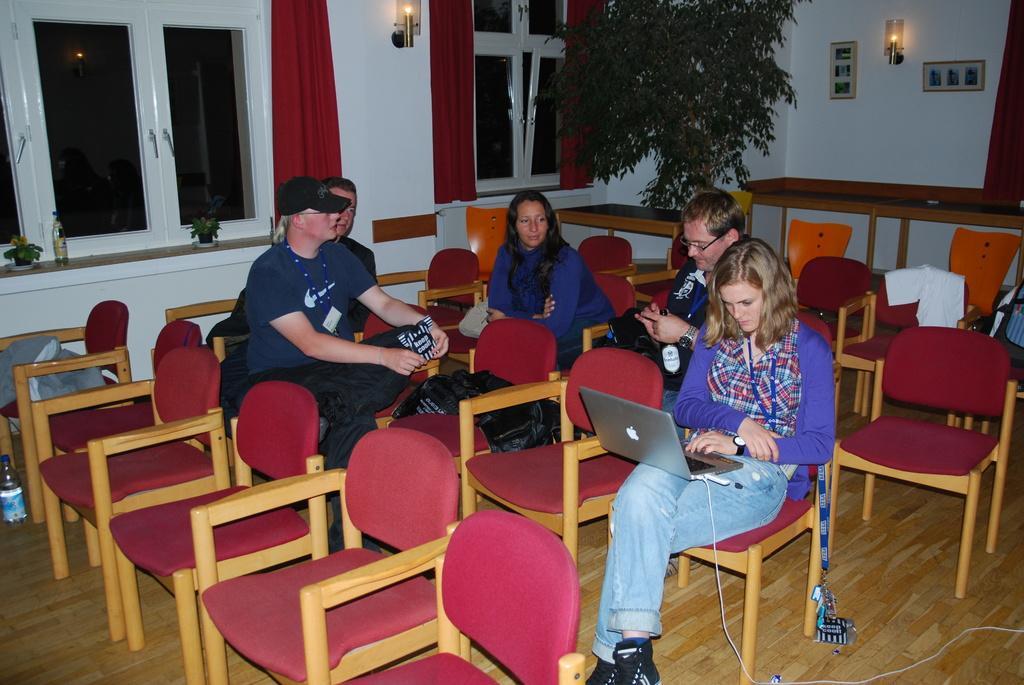In one or two sentences, can you explain what this image depicts? This is a room there are few chairs here and few people are sitting on the chair. here a woman is working on laptop. In the background we can see windows,curtain,light and a plant. 